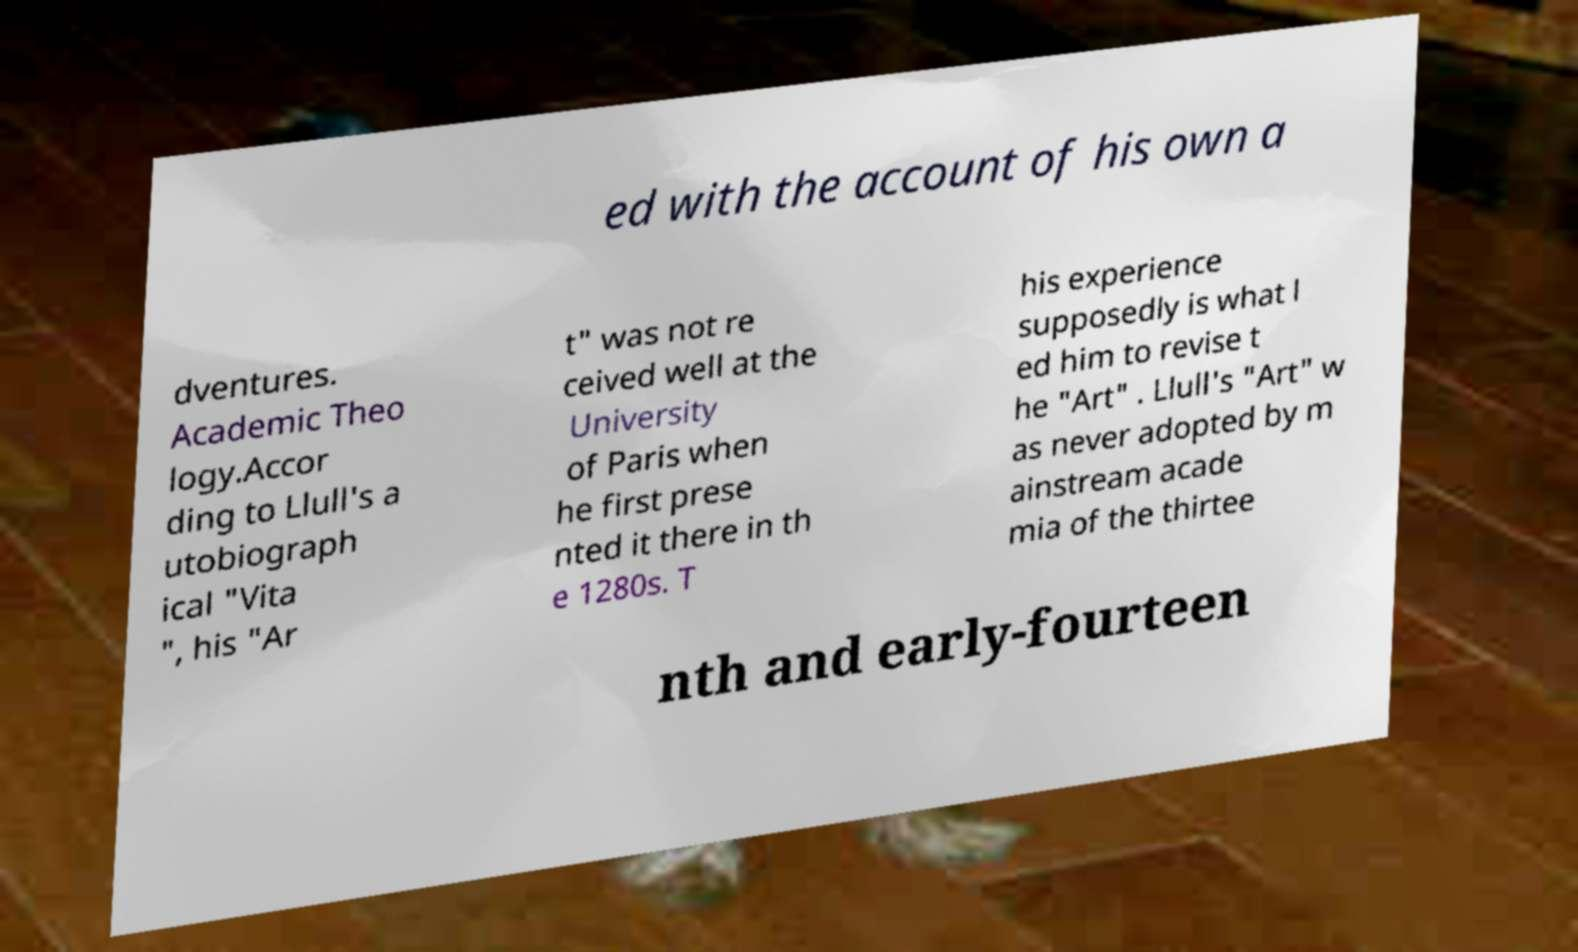Could you assist in decoding the text presented in this image and type it out clearly? ed with the account of his own a dventures. Academic Theo logy.Accor ding to Llull's a utobiograph ical "Vita ", his "Ar t" was not re ceived well at the University of Paris when he first prese nted it there in th e 1280s. T his experience supposedly is what l ed him to revise t he "Art" . Llull's "Art" w as never adopted by m ainstream acade mia of the thirtee nth and early-fourteen 